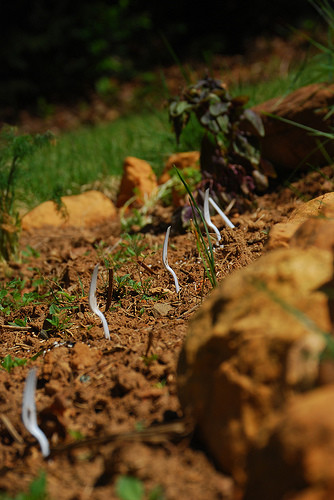<image>
Is the fork above the dirt? Yes. The fork is positioned above the dirt in the vertical space, higher up in the scene. 